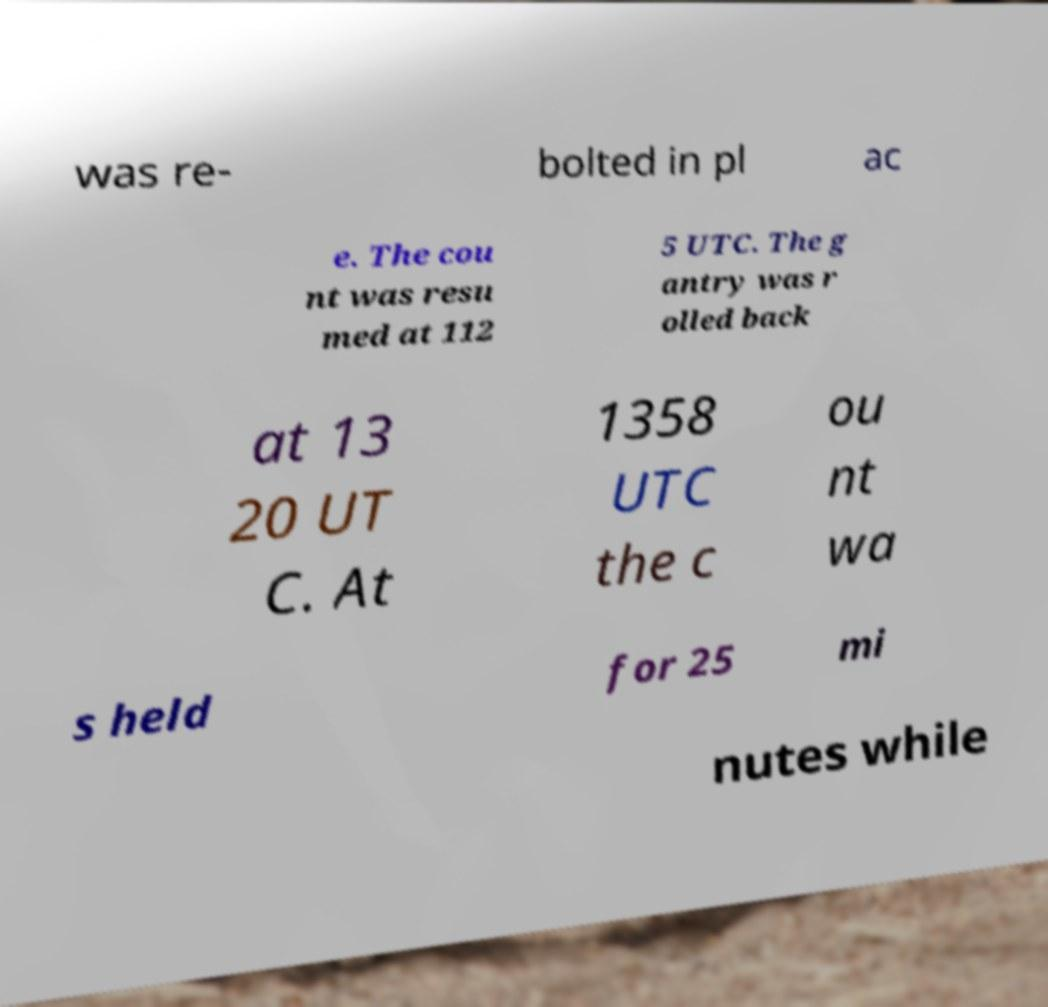Can you read and provide the text displayed in the image?This photo seems to have some interesting text. Can you extract and type it out for me? was re- bolted in pl ac e. The cou nt was resu med at 112 5 UTC. The g antry was r olled back at 13 20 UT C. At 1358 UTC the c ou nt wa s held for 25 mi nutes while 